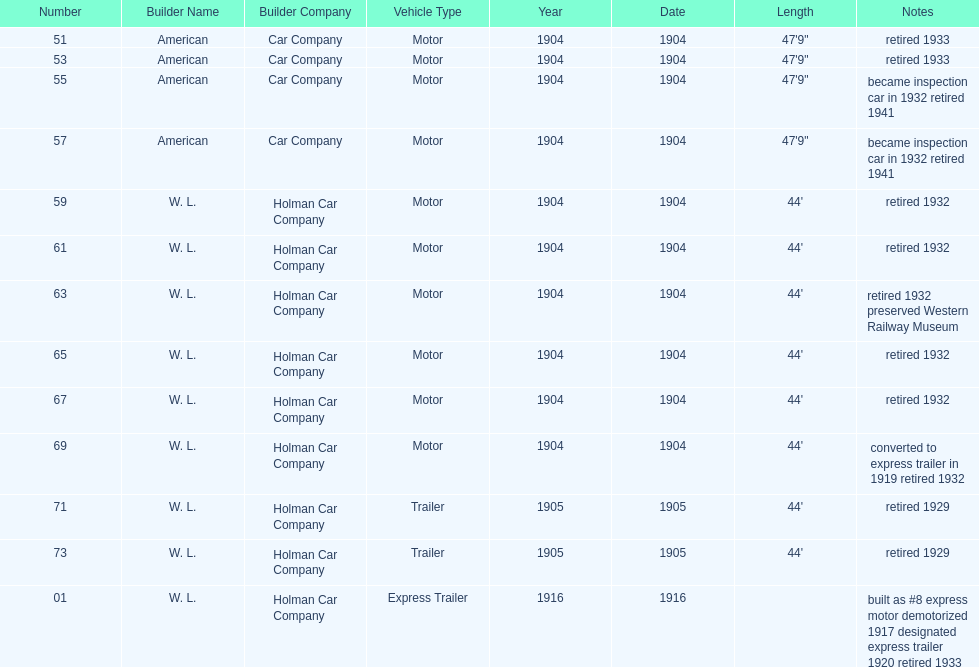Did american car company or w.l. holman car company build cars that were 44' in length? W. L. Holman Car Company. 